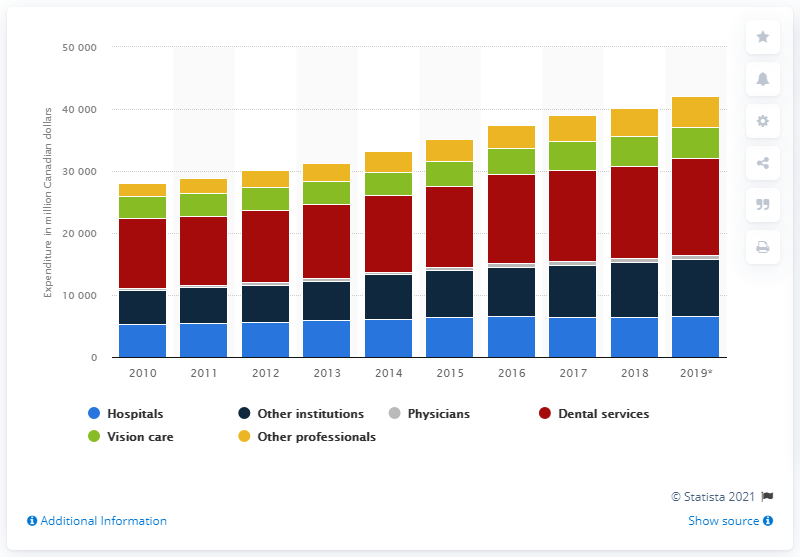Point out several critical features in this image. The estimated amount of dental service expenditures in Canada's private sector in 2019 was 15,646.9. 